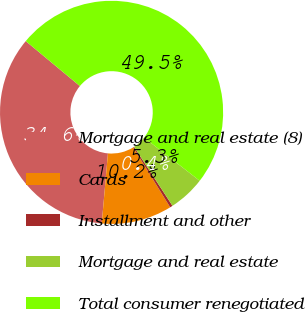Convert chart. <chart><loc_0><loc_0><loc_500><loc_500><pie_chart><fcel>Mortgage and real estate (8)<fcel>Cards<fcel>Installment and other<fcel>Mortgage and real estate<fcel>Total consumer renegotiated<nl><fcel>34.63%<fcel>10.21%<fcel>0.39%<fcel>5.3%<fcel>49.48%<nl></chart> 